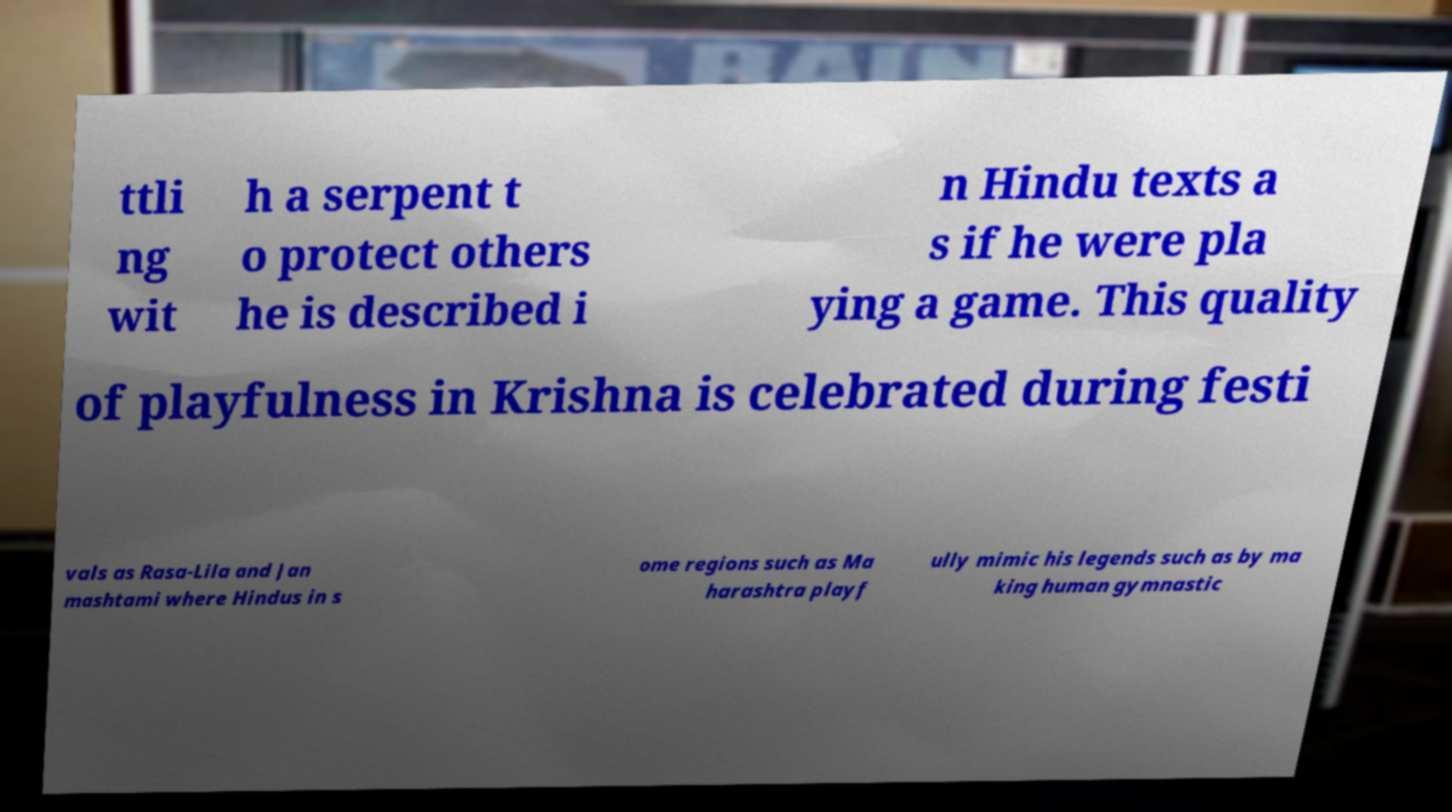Could you assist in decoding the text presented in this image and type it out clearly? ttli ng wit h a serpent t o protect others he is described i n Hindu texts a s if he were pla ying a game. This quality of playfulness in Krishna is celebrated during festi vals as Rasa-Lila and Jan mashtami where Hindus in s ome regions such as Ma harashtra playf ully mimic his legends such as by ma king human gymnastic 